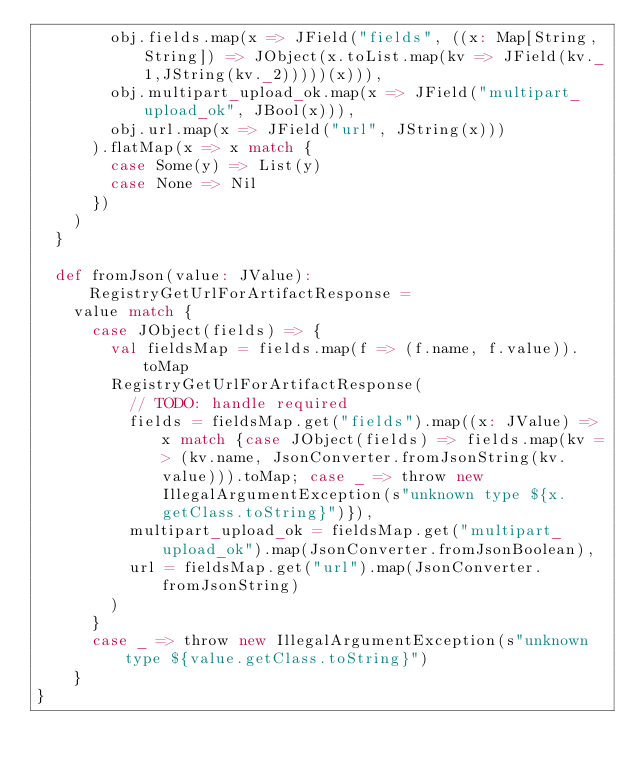<code> <loc_0><loc_0><loc_500><loc_500><_Scala_>        obj.fields.map(x => JField("fields", ((x: Map[String,String]) => JObject(x.toList.map(kv => JField(kv._1,JString(kv._2)))))(x))),
        obj.multipart_upload_ok.map(x => JField("multipart_upload_ok", JBool(x))),
        obj.url.map(x => JField("url", JString(x)))
      ).flatMap(x => x match {
        case Some(y) => List(y)
        case None => Nil
      })
    )
  }

  def fromJson(value: JValue): RegistryGetUrlForArtifactResponse =
    value match {
      case JObject(fields) => {
        val fieldsMap = fields.map(f => (f.name, f.value)).toMap
        RegistryGetUrlForArtifactResponse(
          // TODO: handle required
          fields = fieldsMap.get("fields").map((x: JValue) => x match {case JObject(fields) => fields.map(kv => (kv.name, JsonConverter.fromJsonString(kv.value))).toMap; case _ => throw new IllegalArgumentException(s"unknown type ${x.getClass.toString}")}),
          multipart_upload_ok = fieldsMap.get("multipart_upload_ok").map(JsonConverter.fromJsonBoolean),
          url = fieldsMap.get("url").map(JsonConverter.fromJsonString)
        )
      }
      case _ => throw new IllegalArgumentException(s"unknown type ${value.getClass.toString}")
    }
}
</code> 